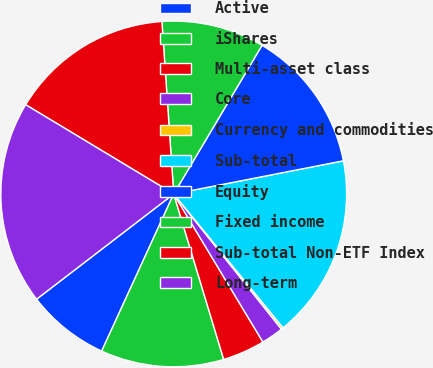<chart> <loc_0><loc_0><loc_500><loc_500><pie_chart><fcel>Active<fcel>iShares<fcel>Multi-asset class<fcel>Core<fcel>Currency and commodities<fcel>Sub-total<fcel>Equity<fcel>Fixed income<fcel>Sub-total Non-ETF Index<fcel>Long-term<nl><fcel>7.74%<fcel>11.51%<fcel>3.96%<fcel>2.08%<fcel>0.19%<fcel>17.17%<fcel>13.4%<fcel>9.62%<fcel>15.28%<fcel>19.05%<nl></chart> 